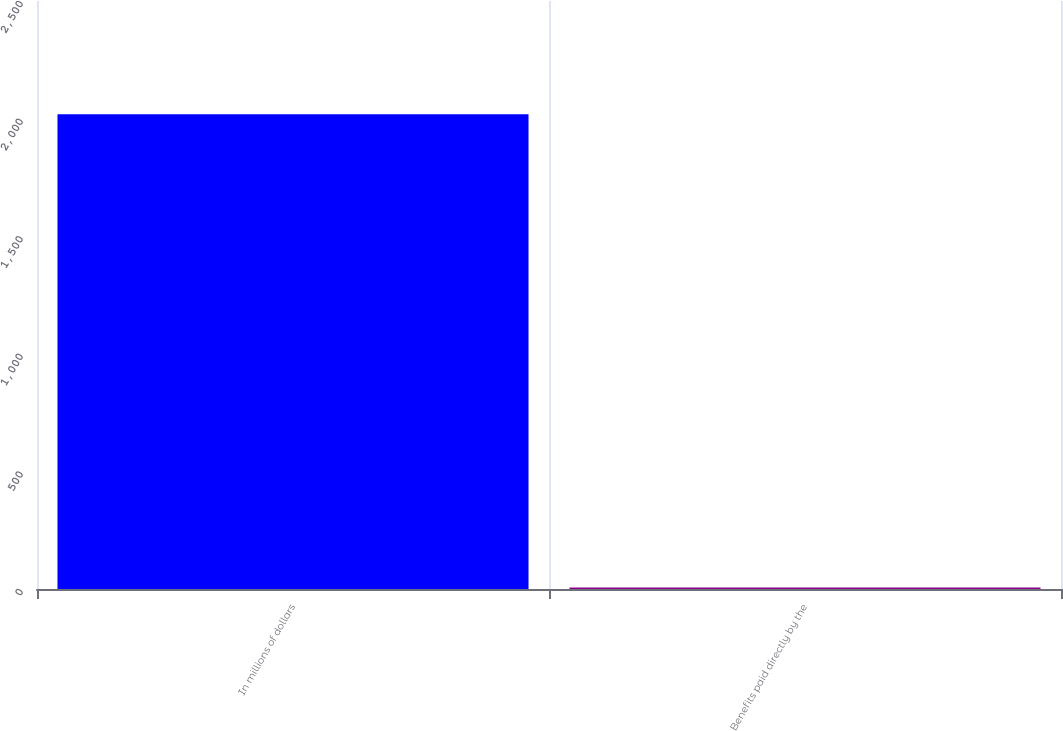Convert chart. <chart><loc_0><loc_0><loc_500><loc_500><bar_chart><fcel>In millions of dollars<fcel>Benefits paid directly by the<nl><fcel>2018<fcel>6<nl></chart> 